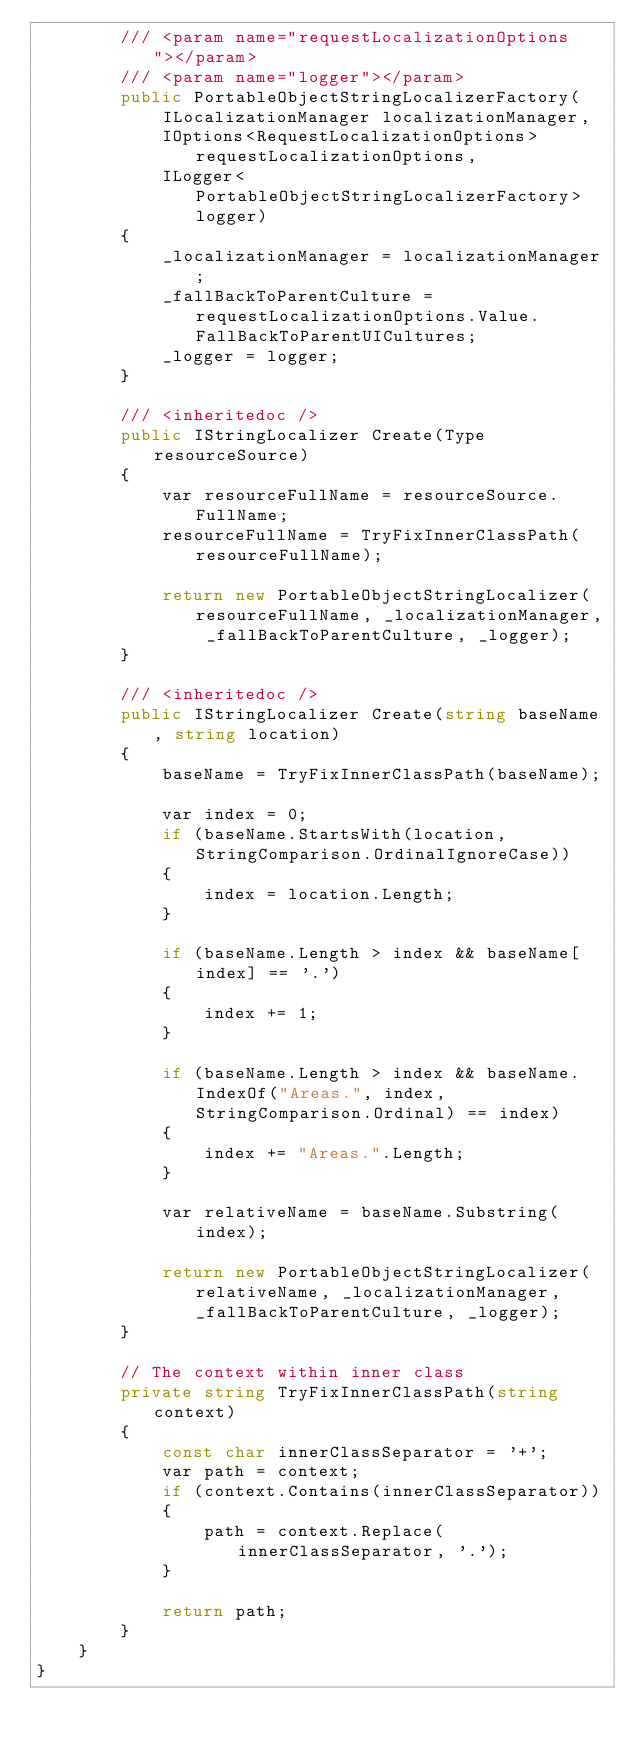Convert code to text. <code><loc_0><loc_0><loc_500><loc_500><_C#_>        /// <param name="requestLocalizationOptions"></param>
        /// <param name="logger"></param>
        public PortableObjectStringLocalizerFactory(
            ILocalizationManager localizationManager,
            IOptions<RequestLocalizationOptions> requestLocalizationOptions,
            ILogger<PortableObjectStringLocalizerFactory> logger)
        {
            _localizationManager = localizationManager;
            _fallBackToParentCulture = requestLocalizationOptions.Value.FallBackToParentUICultures;
            _logger = logger;
        }

        /// <inheritedoc />
        public IStringLocalizer Create(Type resourceSource)
        {
            var resourceFullName = resourceSource.FullName;
            resourceFullName = TryFixInnerClassPath(resourceFullName);

            return new PortableObjectStringLocalizer(resourceFullName, _localizationManager, _fallBackToParentCulture, _logger);
        }

        /// <inheritedoc />
        public IStringLocalizer Create(string baseName, string location)
        {
            baseName = TryFixInnerClassPath(baseName);

            var index = 0;
            if (baseName.StartsWith(location, StringComparison.OrdinalIgnoreCase))
            {
                index = location.Length;
            }

            if (baseName.Length > index && baseName[index] == '.')
            {
                index += 1;
            }

            if (baseName.Length > index && baseName.IndexOf("Areas.", index, StringComparison.Ordinal) == index)
            {
                index += "Areas.".Length;
            }

            var relativeName = baseName.Substring(index);

            return new PortableObjectStringLocalizer(relativeName, _localizationManager, _fallBackToParentCulture, _logger);
        }

        // The context within inner class
        private string TryFixInnerClassPath(string context)
        {
            const char innerClassSeparator = '+';
            var path = context;
            if (context.Contains(innerClassSeparator))
            {
                path = context.Replace(innerClassSeparator, '.');
            }

            return path;
        }
    }
}
</code> 